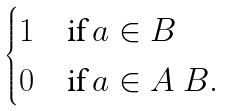<formula> <loc_0><loc_0><loc_500><loc_500>\begin{cases} 1 & \text {if} \, a \in B \\ 0 & \text {if} \, a \in A \ B . \end{cases}</formula> 